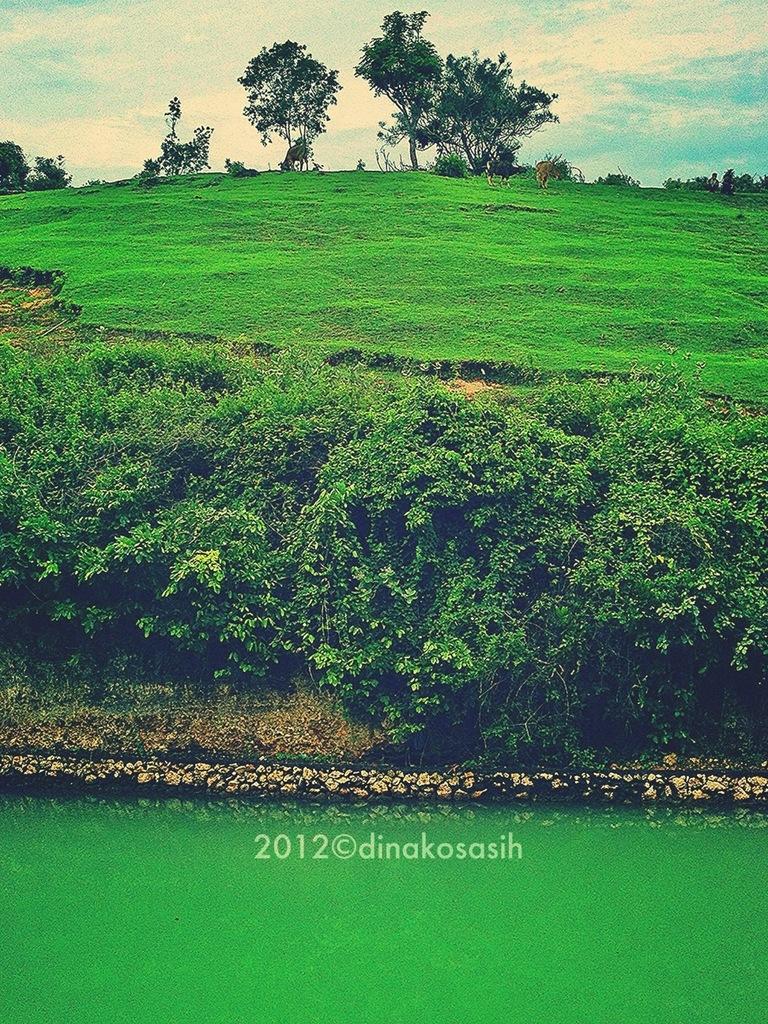Please provide a concise description of this image. In this image I can see few trees, green grass and the green color water. The sky is in blue and white color. 